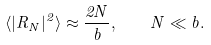<formula> <loc_0><loc_0><loc_500><loc_500>\langle | R _ { N } | ^ { 2 } \rangle \approx \frac { 2 N } { b } , \quad N \ll b .</formula> 